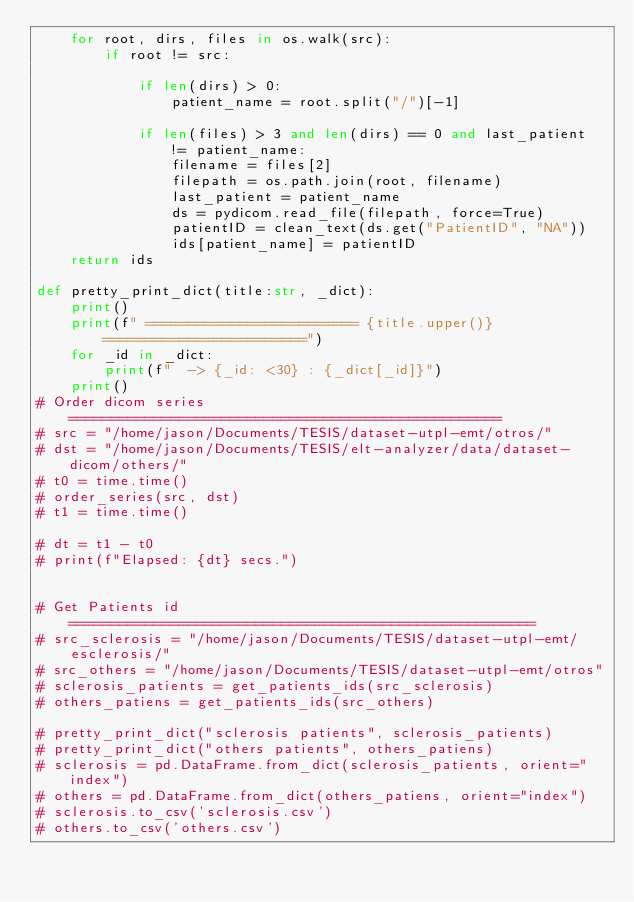Convert code to text. <code><loc_0><loc_0><loc_500><loc_500><_Python_>    for root, dirs, files in os.walk(src):
        if root != src:

            if len(dirs) > 0:
                patient_name = root.split("/")[-1]

            if len(files) > 3 and len(dirs) == 0 and last_patient != patient_name:              
                filename = files[2]
                filepath = os.path.join(root, filename)
                last_patient = patient_name
                ds = pydicom.read_file(filepath, force=True)
                patientID = clean_text(ds.get("PatientID", "NA"))
                ids[patient_name] = patientID
    return ids

def pretty_print_dict(title:str, _dict):
    print()
    print(f" ========================= {title.upper()} ========================")
    for _id in _dict:
        print(f"  -> {_id: <30} : {_dict[_id]}")
    print()
# Order dicom series ===================================================
# src = "/home/jason/Documents/TESIS/dataset-utpl-emt/otros/"
# dst = "/home/jason/Documents/TESIS/elt-analyzer/data/dataset-dicom/others/"
# t0 = time.time()
# order_series(src, dst)
# t1 = time.time()

# dt = t1 - t0
# print(f"Elapsed: {dt} secs.")


# Get Patients id =======================================================
# src_sclerosis = "/home/jason/Documents/TESIS/dataset-utpl-emt/esclerosis/"
# src_others = "/home/jason/Documents/TESIS/dataset-utpl-emt/otros"
# sclerosis_patients = get_patients_ids(src_sclerosis)
# others_patiens = get_patients_ids(src_others)

# pretty_print_dict("sclerosis patients", sclerosis_patients)
# pretty_print_dict("others patients", others_patiens)
# sclerosis = pd.DataFrame.from_dict(sclerosis_patients, orient="index")
# others = pd.DataFrame.from_dict(others_patiens, orient="index")
# sclerosis.to_csv('sclerosis.csv')
# others.to_csv('others.csv')


    
    </code> 